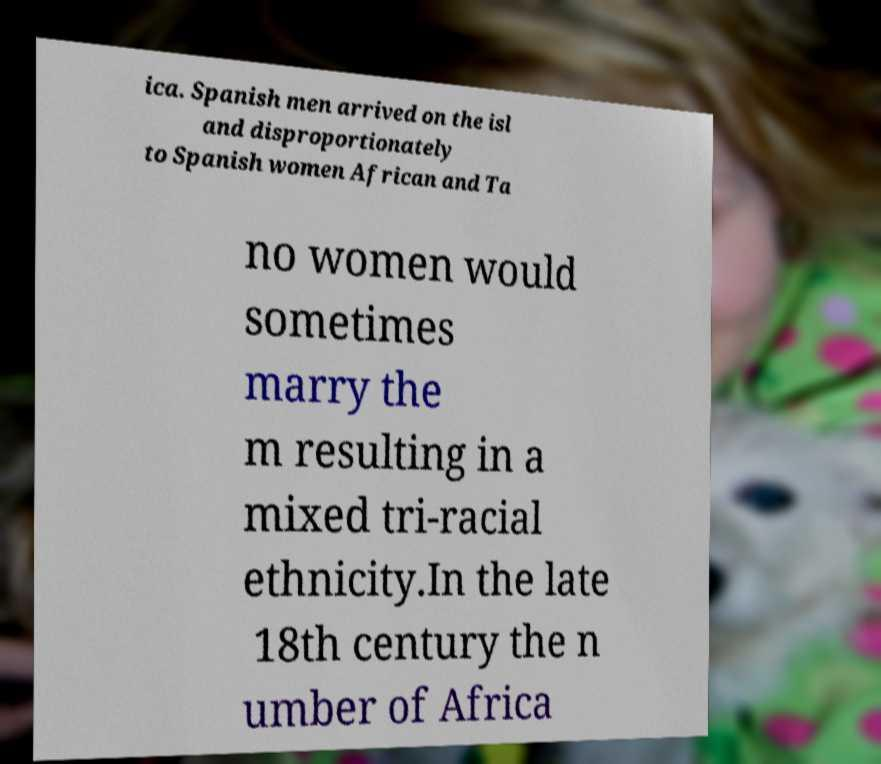For documentation purposes, I need the text within this image transcribed. Could you provide that? ica. Spanish men arrived on the isl and disproportionately to Spanish women African and Ta no women would sometimes marry the m resulting in a mixed tri-racial ethnicity.In the late 18th century the n umber of Africa 